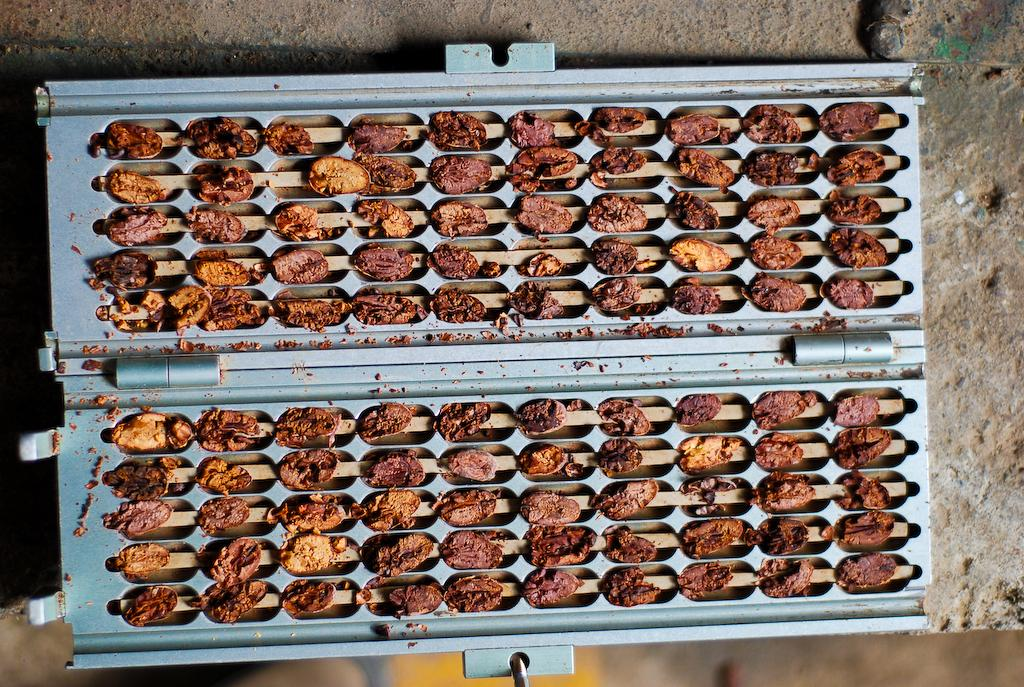What is the main object in the image? There is a machine in the image. What can be found inside the machine? There are food items in the machine. What type of club is located in the town shown in the image? There is no town or club present in the image; it only features a machine with food items inside. 